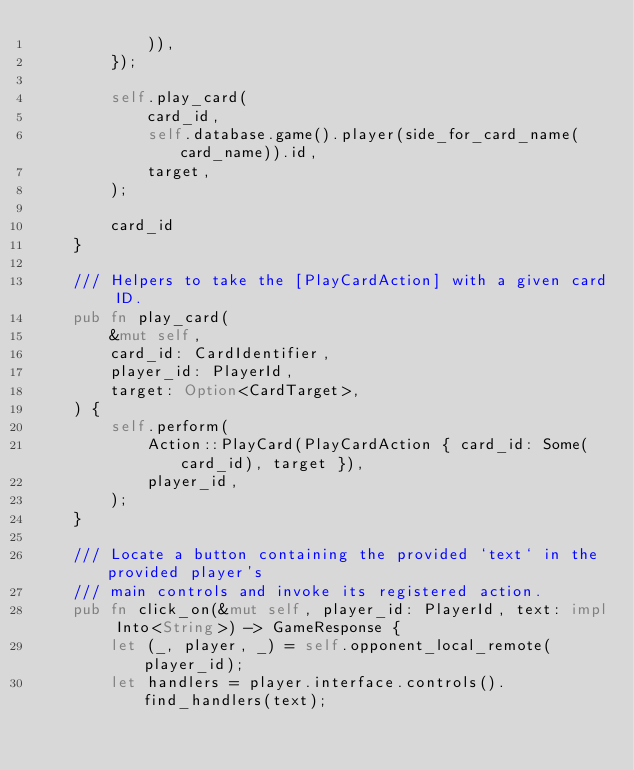Convert code to text. <code><loc_0><loc_0><loc_500><loc_500><_Rust_>            )),
        });

        self.play_card(
            card_id,
            self.database.game().player(side_for_card_name(card_name)).id,
            target,
        );

        card_id
    }

    /// Helpers to take the [PlayCardAction] with a given card ID.
    pub fn play_card(
        &mut self,
        card_id: CardIdentifier,
        player_id: PlayerId,
        target: Option<CardTarget>,
    ) {
        self.perform(
            Action::PlayCard(PlayCardAction { card_id: Some(card_id), target }),
            player_id,
        );
    }

    /// Locate a button containing the provided `text` in the provided player's
    /// main controls and invoke its registered action.
    pub fn click_on(&mut self, player_id: PlayerId, text: impl Into<String>) -> GameResponse {
        let (_, player, _) = self.opponent_local_remote(player_id);
        let handlers = player.interface.controls().find_handlers(text);</code> 